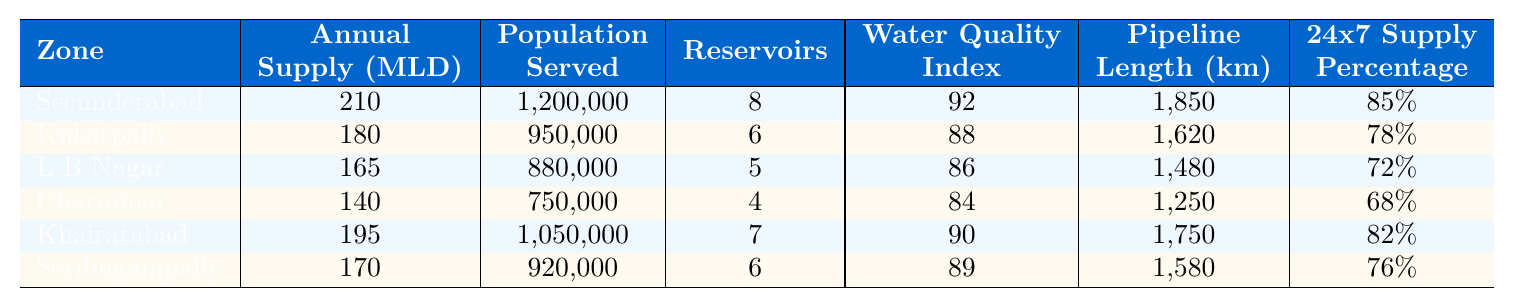What is the annual water supply (in MLD) for Secunderabad? The table indicates that the annual supply for Secunderabad is listed as 210 MLD.
Answer: 210 MLD Which zone has the highest population served? By comparing the populations served across all zones, Secunderabad serves the largest population at 1,200,000.
Answer: Secunderabad What is the water quality index for Khairatabad? The water quality index for Khairatabad is mentioned in the table as 90.
Answer: 90 How many reservoirs does Charminar have? The table lists Charminar as having 4 reservoirs.
Answer: 4 What is the pipeline length in L B Nagar? The length of the pipeline in L B Nagar is specified in the table as 1,480 km.
Answer: 1,480 km Which zone has the lowest percentage of 24x7 water supply? Looking at the 24x7 supply percentages, Charminar has the lowest at 68%.
Answer: Charminar What is the total annual water supply (in MLD) for all the zones combined? Summing the annual supplies: 210 + 180 + 165 + 140 + 195 + 170 = 1,060 MLD provides the total annual supply.
Answer: 1,060 MLD What is the average water quality index across all zones? Calculate the average by adding the water quality indices: (92 + 88 + 86 + 84 + 90 + 89) = 519 and dividing by 6 gives the average: 519/6 = 86.5.
Answer: 86.5 Is the majority of the zones providing over 75% 24x7 water supply? Counting the percentages, only Secunderabad (85%) and Khairatabad (82%) exceed 75%, which is not the majority of the 6 zones.
Answer: No Which zone has the most reservoirs? By checking the number of reservoirs, Secunderabad has the highest number at 8.
Answer: Secunderabad How much higher is the annual supply of water in Secunderabad compared to Charminar? Secunderabad provides 210 MLD and Charminar provides 140 MLD. The difference is 210 - 140 = 70 MLD.
Answer: 70 MLD 